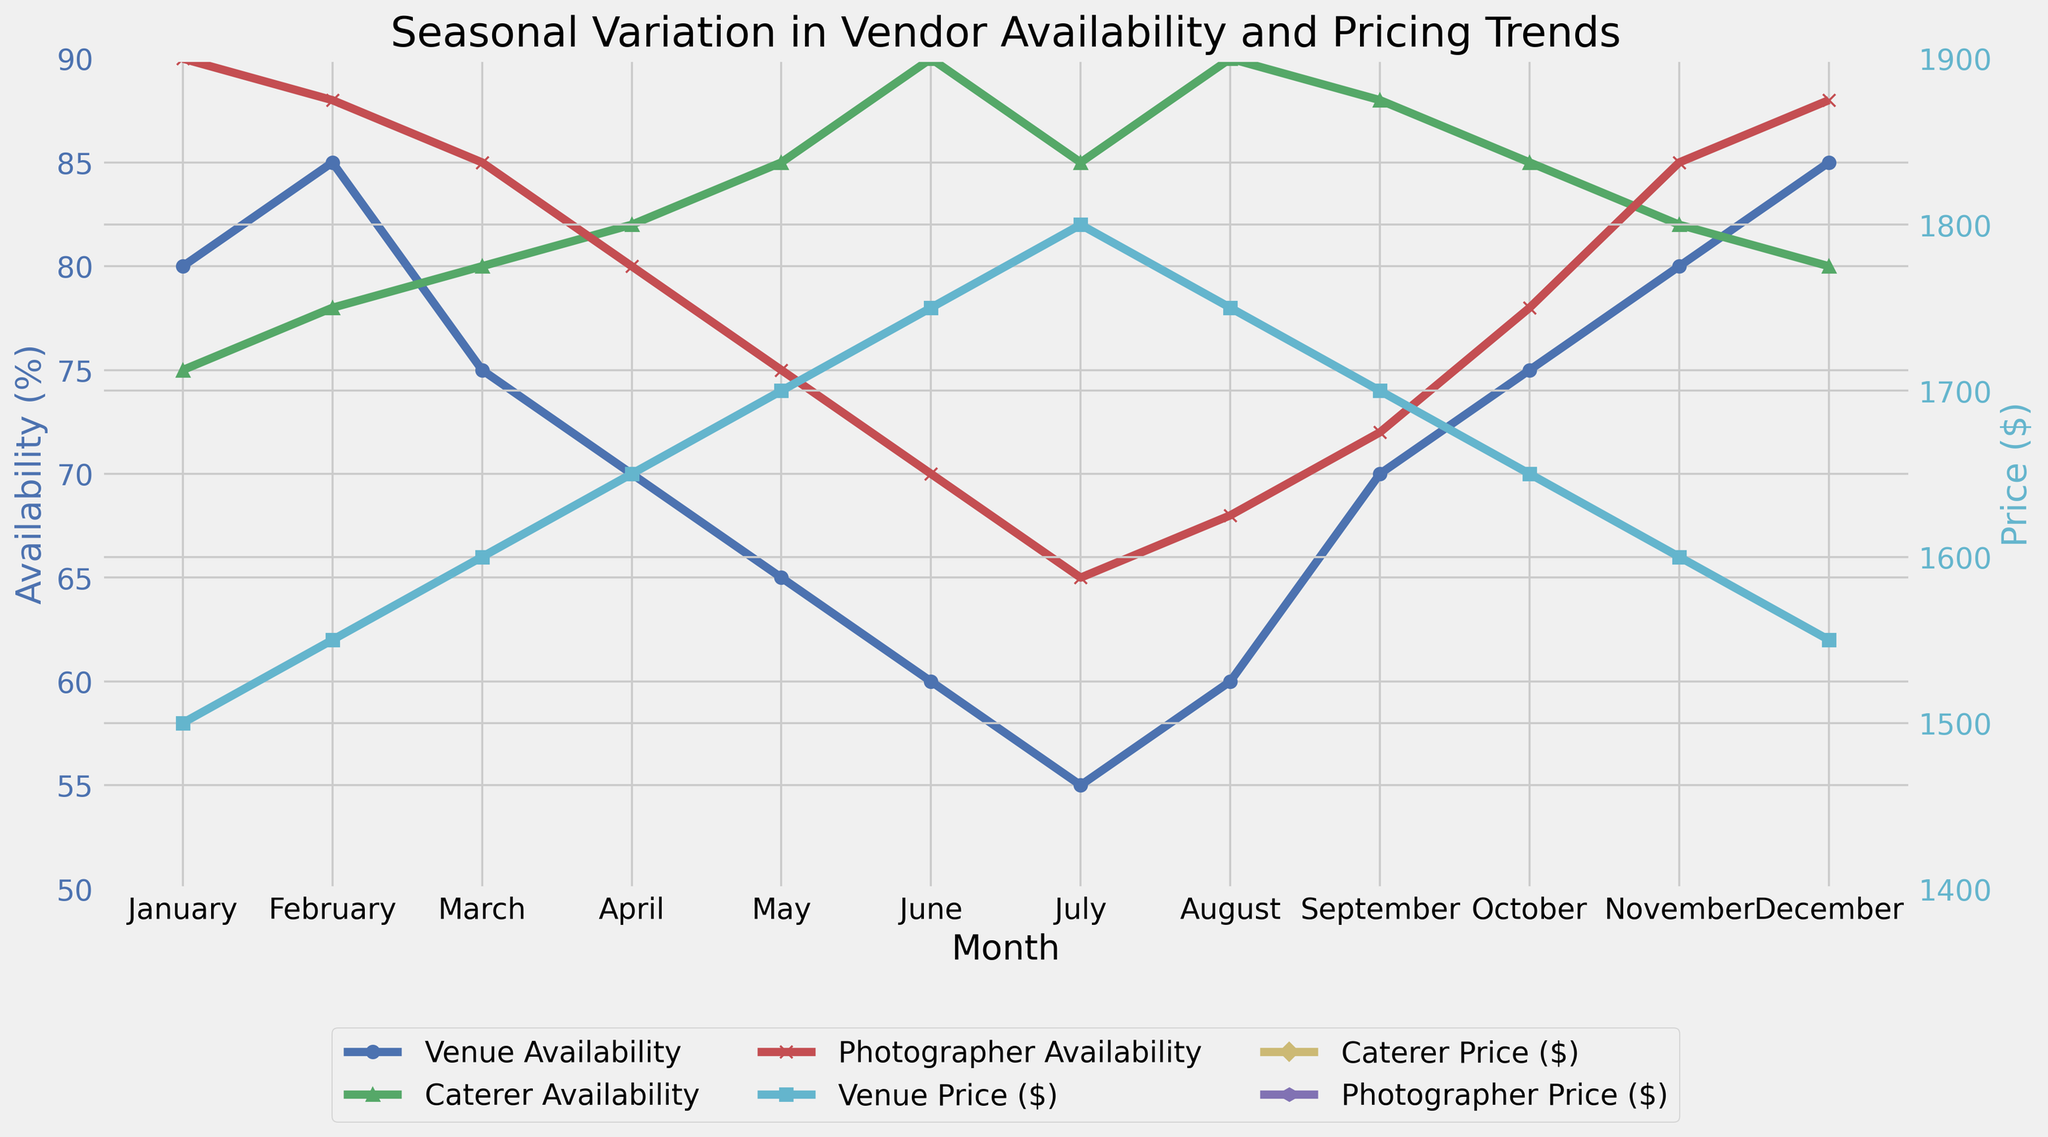what month has the lowest venue availability? To find the month with the lowest venue availability, look at the blue line that represents Venue Availability and identify the minimum point, which occurs in July.
Answer: July which month has the highest photographer price? To find the month with the highest photographer price, look at the magenta line representing Photographer Price ($) and identify the maximum point, which occurs in July.
Answer: July compare caterer availability in January and June Look at the green line representing Caterer Availability and compare the points for January and June. January is at 75% and June is at 90%.
Answer: June what is the average venue price over the year? First, sum the venue prices for each month (1500 + 1550 + 1600 + 1650 + 1700 + 1750 + 1800 + 1750 + 1700 + 1650 + 1600 + 1550 = 19800). Then, divide by 12 to get the average, 19800 / 12.
Answer: 1650 in which months is caterer availability higher than venue availability? Compare the green (Caterer Availability) and blue (Venue Availability) lines. The months where the green line is above the blue line are June, July, August, and September.
Answer: June, July, August, September what is the difference in venue availability between January and July? Venue Availability in January is 80%, and in July it is 55%. Subtract to find the difference, 80% - 55%.
Answer: 25% how does the cost of a photographer change from January to December? Look at the magenta line (Photographer Price $) and compare the points for January ($2500) and December ($2650).
Answer: Increases by $150 which vendor has the most stable pricing trend throughout the year? Look at the lines that represent pricing trends. The blue and green lines for Venue and Caterer prices exhibit a more consistent trend, while the magenta line for Photographer shows more fluctuation.
Answer: Venue, Caterer What is the average photographer availability in summer months (June, July, August)? Sum the Photographer Availability for June (70), July (65), and August (68). Then, divide by 3 to get the average (203/3).
Answer: 67.67% Which vendor shows a price peak mid-year? Look at the lines representing price trends and identify the mid-year peak, which occurs for Caterers in June, July, and August with the highest value in July.
Answer: Caterers 